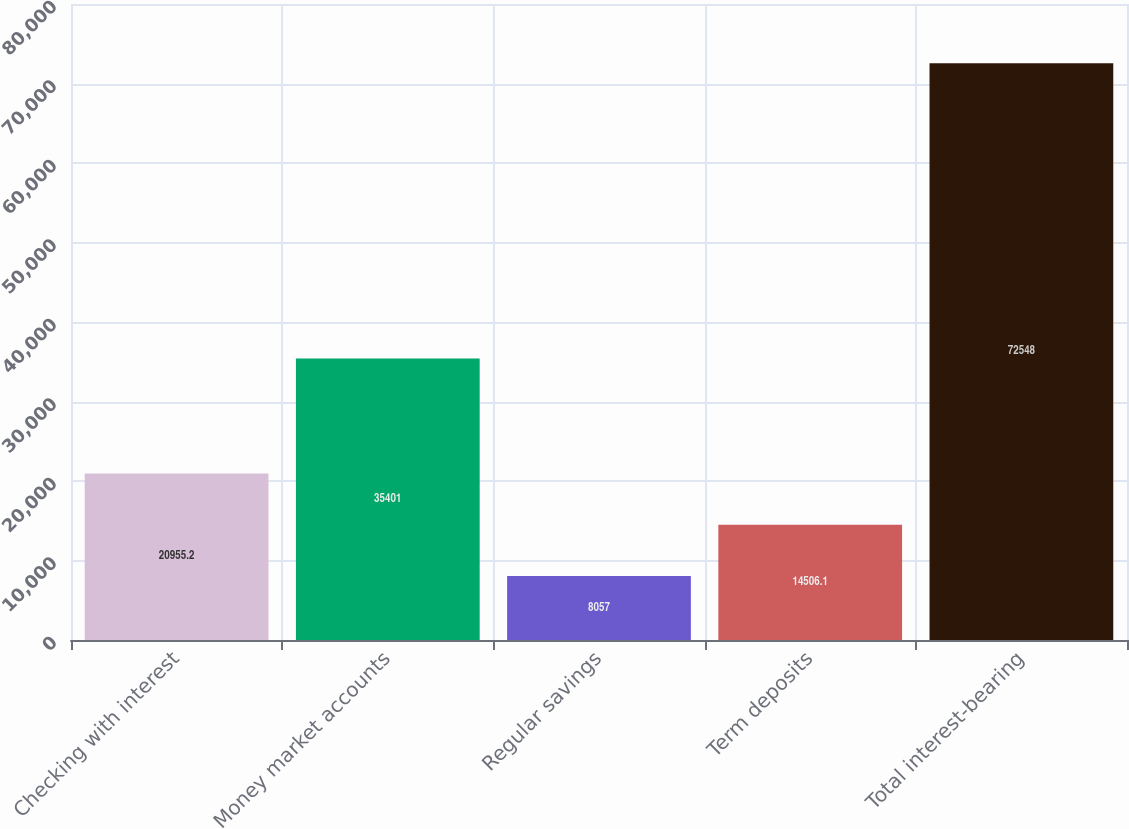Convert chart. <chart><loc_0><loc_0><loc_500><loc_500><bar_chart><fcel>Checking with interest<fcel>Money market accounts<fcel>Regular savings<fcel>Term deposits<fcel>Total interest-bearing<nl><fcel>20955.2<fcel>35401<fcel>8057<fcel>14506.1<fcel>72548<nl></chart> 